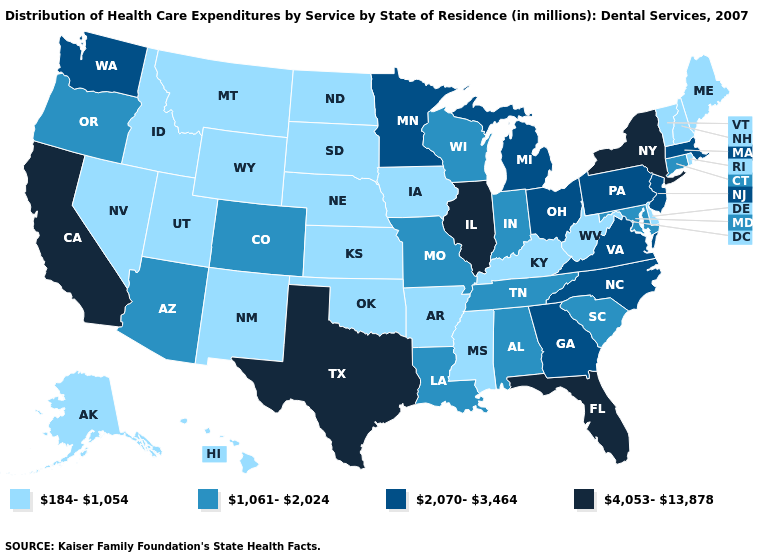What is the value of Utah?
Give a very brief answer. 184-1,054. Name the states that have a value in the range 184-1,054?
Quick response, please. Alaska, Arkansas, Delaware, Hawaii, Idaho, Iowa, Kansas, Kentucky, Maine, Mississippi, Montana, Nebraska, Nevada, New Hampshire, New Mexico, North Dakota, Oklahoma, Rhode Island, South Dakota, Utah, Vermont, West Virginia, Wyoming. Does Montana have the highest value in the USA?
Short answer required. No. What is the highest value in states that border Tennessee?
Short answer required. 2,070-3,464. Does Minnesota have a lower value than Kansas?
Be succinct. No. Does Illinois have the same value as Texas?
Write a very short answer. Yes. Which states have the lowest value in the Northeast?
Be succinct. Maine, New Hampshire, Rhode Island, Vermont. Which states have the highest value in the USA?
Concise answer only. California, Florida, Illinois, New York, Texas. What is the highest value in the USA?
Give a very brief answer. 4,053-13,878. Among the states that border Massachusetts , does Connecticut have the lowest value?
Short answer required. No. What is the value of Pennsylvania?
Be succinct. 2,070-3,464. Does Iowa have the lowest value in the MidWest?
Keep it brief. Yes. Name the states that have a value in the range 184-1,054?
Short answer required. Alaska, Arkansas, Delaware, Hawaii, Idaho, Iowa, Kansas, Kentucky, Maine, Mississippi, Montana, Nebraska, Nevada, New Hampshire, New Mexico, North Dakota, Oklahoma, Rhode Island, South Dakota, Utah, Vermont, West Virginia, Wyoming. Name the states that have a value in the range 1,061-2,024?
Write a very short answer. Alabama, Arizona, Colorado, Connecticut, Indiana, Louisiana, Maryland, Missouri, Oregon, South Carolina, Tennessee, Wisconsin. 